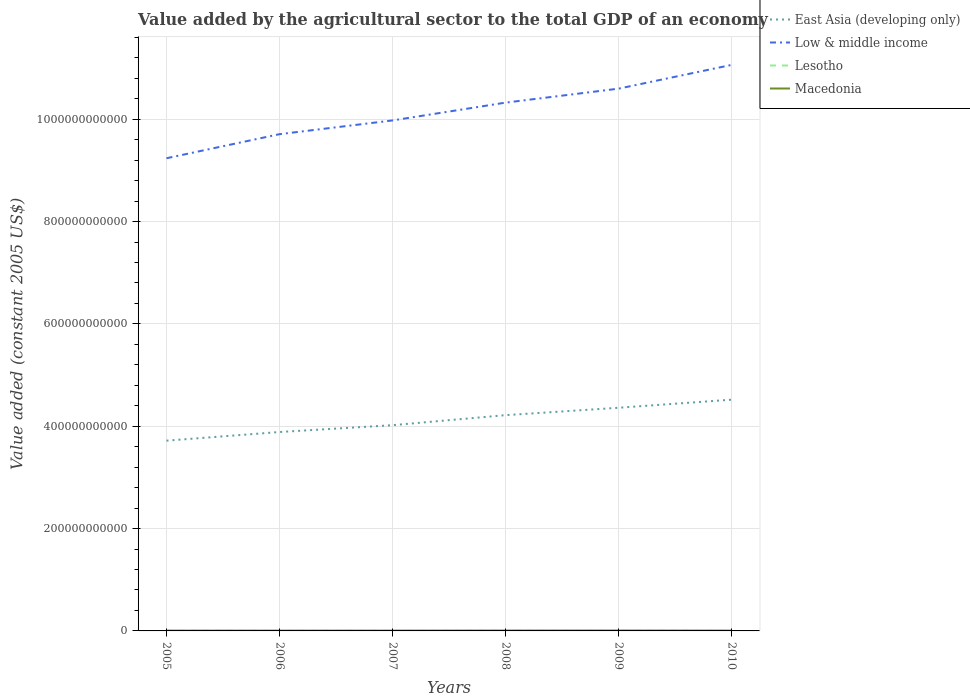How many different coloured lines are there?
Offer a very short reply. 4. Does the line corresponding to Low & middle income intersect with the line corresponding to East Asia (developing only)?
Your response must be concise. No. Is the number of lines equal to the number of legend labels?
Offer a very short reply. Yes. Across all years, what is the maximum value added by the agricultural sector in Lesotho?
Make the answer very short. 1.01e+08. What is the total value added by the agricultural sector in East Asia (developing only) in the graph?
Ensure brevity in your answer.  -1.58e+1. What is the difference between the highest and the second highest value added by the agricultural sector in Low & middle income?
Give a very brief answer. 1.82e+11. What is the difference between the highest and the lowest value added by the agricultural sector in Low & middle income?
Offer a very short reply. 3. How many lines are there?
Provide a succinct answer. 4. How many years are there in the graph?
Ensure brevity in your answer.  6. What is the difference between two consecutive major ticks on the Y-axis?
Your answer should be very brief. 2.00e+11. Does the graph contain grids?
Your response must be concise. Yes. What is the title of the graph?
Your answer should be very brief. Value added by the agricultural sector to the total GDP of an economy. Does "Europe(all income levels)" appear as one of the legend labels in the graph?
Ensure brevity in your answer.  No. What is the label or title of the X-axis?
Your response must be concise. Years. What is the label or title of the Y-axis?
Provide a short and direct response. Value added (constant 2005 US$). What is the Value added (constant 2005 US$) of East Asia (developing only) in 2005?
Ensure brevity in your answer.  3.72e+11. What is the Value added (constant 2005 US$) in Low & middle income in 2005?
Offer a terse response. 9.24e+11. What is the Value added (constant 2005 US$) of Lesotho in 2005?
Make the answer very short. 1.13e+08. What is the Value added (constant 2005 US$) in Macedonia in 2005?
Give a very brief answer. 6.09e+08. What is the Value added (constant 2005 US$) in East Asia (developing only) in 2006?
Keep it short and to the point. 3.89e+11. What is the Value added (constant 2005 US$) in Low & middle income in 2006?
Provide a short and direct response. 9.71e+11. What is the Value added (constant 2005 US$) in Lesotho in 2006?
Give a very brief answer. 1.02e+08. What is the Value added (constant 2005 US$) of Macedonia in 2006?
Provide a short and direct response. 6.06e+08. What is the Value added (constant 2005 US$) in East Asia (developing only) in 2007?
Your response must be concise. 4.02e+11. What is the Value added (constant 2005 US$) of Low & middle income in 2007?
Your response must be concise. 9.98e+11. What is the Value added (constant 2005 US$) of Lesotho in 2007?
Keep it short and to the point. 1.01e+08. What is the Value added (constant 2005 US$) in Macedonia in 2007?
Ensure brevity in your answer.  6.19e+08. What is the Value added (constant 2005 US$) of East Asia (developing only) in 2008?
Offer a terse response. 4.22e+11. What is the Value added (constant 2005 US$) in Low & middle income in 2008?
Provide a short and direct response. 1.03e+12. What is the Value added (constant 2005 US$) in Lesotho in 2008?
Keep it short and to the point. 1.17e+08. What is the Value added (constant 2005 US$) in Macedonia in 2008?
Offer a terse response. 7.55e+08. What is the Value added (constant 2005 US$) in East Asia (developing only) in 2009?
Your response must be concise. 4.36e+11. What is the Value added (constant 2005 US$) in Low & middle income in 2009?
Your answer should be very brief. 1.06e+12. What is the Value added (constant 2005 US$) of Lesotho in 2009?
Make the answer very short. 1.11e+08. What is the Value added (constant 2005 US$) in Macedonia in 2009?
Your response must be concise. 7.81e+08. What is the Value added (constant 2005 US$) in East Asia (developing only) in 2010?
Provide a short and direct response. 4.52e+11. What is the Value added (constant 2005 US$) of Low & middle income in 2010?
Keep it short and to the point. 1.11e+12. What is the Value added (constant 2005 US$) of Lesotho in 2010?
Ensure brevity in your answer.  1.22e+08. What is the Value added (constant 2005 US$) in Macedonia in 2010?
Give a very brief answer. 6.76e+08. Across all years, what is the maximum Value added (constant 2005 US$) in East Asia (developing only)?
Your answer should be very brief. 4.52e+11. Across all years, what is the maximum Value added (constant 2005 US$) of Low & middle income?
Provide a succinct answer. 1.11e+12. Across all years, what is the maximum Value added (constant 2005 US$) of Lesotho?
Ensure brevity in your answer.  1.22e+08. Across all years, what is the maximum Value added (constant 2005 US$) in Macedonia?
Your answer should be compact. 7.81e+08. Across all years, what is the minimum Value added (constant 2005 US$) of East Asia (developing only)?
Your answer should be compact. 3.72e+11. Across all years, what is the minimum Value added (constant 2005 US$) of Low & middle income?
Ensure brevity in your answer.  9.24e+11. Across all years, what is the minimum Value added (constant 2005 US$) in Lesotho?
Your answer should be compact. 1.01e+08. Across all years, what is the minimum Value added (constant 2005 US$) of Macedonia?
Offer a terse response. 6.06e+08. What is the total Value added (constant 2005 US$) of East Asia (developing only) in the graph?
Ensure brevity in your answer.  2.47e+12. What is the total Value added (constant 2005 US$) in Low & middle income in the graph?
Make the answer very short. 6.09e+12. What is the total Value added (constant 2005 US$) in Lesotho in the graph?
Your response must be concise. 6.67e+08. What is the total Value added (constant 2005 US$) of Macedonia in the graph?
Your response must be concise. 4.05e+09. What is the difference between the Value added (constant 2005 US$) of East Asia (developing only) in 2005 and that in 2006?
Give a very brief answer. -1.69e+1. What is the difference between the Value added (constant 2005 US$) of Low & middle income in 2005 and that in 2006?
Your answer should be compact. -4.70e+1. What is the difference between the Value added (constant 2005 US$) of Lesotho in 2005 and that in 2006?
Your response must be concise. 1.17e+07. What is the difference between the Value added (constant 2005 US$) in Macedonia in 2005 and that in 2006?
Your response must be concise. 3.31e+06. What is the difference between the Value added (constant 2005 US$) in East Asia (developing only) in 2005 and that in 2007?
Provide a succinct answer. -3.03e+1. What is the difference between the Value added (constant 2005 US$) of Low & middle income in 2005 and that in 2007?
Offer a very short reply. -7.39e+1. What is the difference between the Value added (constant 2005 US$) in Lesotho in 2005 and that in 2007?
Your response must be concise. 1.26e+07. What is the difference between the Value added (constant 2005 US$) in Macedonia in 2005 and that in 2007?
Offer a very short reply. -9.75e+06. What is the difference between the Value added (constant 2005 US$) in East Asia (developing only) in 2005 and that in 2008?
Ensure brevity in your answer.  -4.99e+1. What is the difference between the Value added (constant 2005 US$) in Low & middle income in 2005 and that in 2008?
Make the answer very short. -1.09e+11. What is the difference between the Value added (constant 2005 US$) of Lesotho in 2005 and that in 2008?
Ensure brevity in your answer.  -3.69e+06. What is the difference between the Value added (constant 2005 US$) in Macedonia in 2005 and that in 2008?
Provide a succinct answer. -1.46e+08. What is the difference between the Value added (constant 2005 US$) of East Asia (developing only) in 2005 and that in 2009?
Your response must be concise. -6.43e+1. What is the difference between the Value added (constant 2005 US$) in Low & middle income in 2005 and that in 2009?
Offer a very short reply. -1.36e+11. What is the difference between the Value added (constant 2005 US$) of Lesotho in 2005 and that in 2009?
Your answer should be very brief. 2.24e+06. What is the difference between the Value added (constant 2005 US$) in Macedonia in 2005 and that in 2009?
Your answer should be very brief. -1.72e+08. What is the difference between the Value added (constant 2005 US$) of East Asia (developing only) in 2005 and that in 2010?
Provide a succinct answer. -8.01e+1. What is the difference between the Value added (constant 2005 US$) of Low & middle income in 2005 and that in 2010?
Your answer should be compact. -1.82e+11. What is the difference between the Value added (constant 2005 US$) in Lesotho in 2005 and that in 2010?
Provide a succinct answer. -9.10e+06. What is the difference between the Value added (constant 2005 US$) of Macedonia in 2005 and that in 2010?
Your response must be concise. -6.71e+07. What is the difference between the Value added (constant 2005 US$) in East Asia (developing only) in 2006 and that in 2007?
Ensure brevity in your answer.  -1.34e+1. What is the difference between the Value added (constant 2005 US$) of Low & middle income in 2006 and that in 2007?
Make the answer very short. -2.69e+1. What is the difference between the Value added (constant 2005 US$) of Lesotho in 2006 and that in 2007?
Your response must be concise. 9.36e+05. What is the difference between the Value added (constant 2005 US$) in Macedonia in 2006 and that in 2007?
Ensure brevity in your answer.  -1.31e+07. What is the difference between the Value added (constant 2005 US$) of East Asia (developing only) in 2006 and that in 2008?
Keep it short and to the point. -3.30e+1. What is the difference between the Value added (constant 2005 US$) of Low & middle income in 2006 and that in 2008?
Provide a succinct answer. -6.17e+1. What is the difference between the Value added (constant 2005 US$) of Lesotho in 2006 and that in 2008?
Give a very brief answer. -1.54e+07. What is the difference between the Value added (constant 2005 US$) of Macedonia in 2006 and that in 2008?
Make the answer very short. -1.49e+08. What is the difference between the Value added (constant 2005 US$) in East Asia (developing only) in 2006 and that in 2009?
Provide a succinct answer. -4.74e+1. What is the difference between the Value added (constant 2005 US$) in Low & middle income in 2006 and that in 2009?
Your answer should be very brief. -8.90e+1. What is the difference between the Value added (constant 2005 US$) of Lesotho in 2006 and that in 2009?
Offer a very short reply. -9.45e+06. What is the difference between the Value added (constant 2005 US$) of Macedonia in 2006 and that in 2009?
Ensure brevity in your answer.  -1.75e+08. What is the difference between the Value added (constant 2005 US$) of East Asia (developing only) in 2006 and that in 2010?
Your answer should be compact. -6.32e+1. What is the difference between the Value added (constant 2005 US$) in Low & middle income in 2006 and that in 2010?
Your response must be concise. -1.35e+11. What is the difference between the Value added (constant 2005 US$) of Lesotho in 2006 and that in 2010?
Ensure brevity in your answer.  -2.08e+07. What is the difference between the Value added (constant 2005 US$) of Macedonia in 2006 and that in 2010?
Ensure brevity in your answer.  -7.04e+07. What is the difference between the Value added (constant 2005 US$) of East Asia (developing only) in 2007 and that in 2008?
Offer a very short reply. -1.96e+1. What is the difference between the Value added (constant 2005 US$) in Low & middle income in 2007 and that in 2008?
Make the answer very short. -3.48e+1. What is the difference between the Value added (constant 2005 US$) in Lesotho in 2007 and that in 2008?
Make the answer very short. -1.63e+07. What is the difference between the Value added (constant 2005 US$) of Macedonia in 2007 and that in 2008?
Ensure brevity in your answer.  -1.36e+08. What is the difference between the Value added (constant 2005 US$) in East Asia (developing only) in 2007 and that in 2009?
Your answer should be compact. -3.40e+1. What is the difference between the Value added (constant 2005 US$) of Low & middle income in 2007 and that in 2009?
Give a very brief answer. -6.21e+1. What is the difference between the Value added (constant 2005 US$) of Lesotho in 2007 and that in 2009?
Your answer should be very brief. -1.04e+07. What is the difference between the Value added (constant 2005 US$) of Macedonia in 2007 and that in 2009?
Provide a succinct answer. -1.62e+08. What is the difference between the Value added (constant 2005 US$) of East Asia (developing only) in 2007 and that in 2010?
Your answer should be very brief. -4.99e+1. What is the difference between the Value added (constant 2005 US$) of Low & middle income in 2007 and that in 2010?
Your response must be concise. -1.09e+11. What is the difference between the Value added (constant 2005 US$) in Lesotho in 2007 and that in 2010?
Offer a terse response. -2.17e+07. What is the difference between the Value added (constant 2005 US$) of Macedonia in 2007 and that in 2010?
Provide a short and direct response. -5.73e+07. What is the difference between the Value added (constant 2005 US$) of East Asia (developing only) in 2008 and that in 2009?
Give a very brief answer. -1.45e+1. What is the difference between the Value added (constant 2005 US$) of Low & middle income in 2008 and that in 2009?
Offer a very short reply. -2.73e+1. What is the difference between the Value added (constant 2005 US$) of Lesotho in 2008 and that in 2009?
Provide a succinct answer. 5.93e+06. What is the difference between the Value added (constant 2005 US$) of Macedonia in 2008 and that in 2009?
Your answer should be compact. -2.57e+07. What is the difference between the Value added (constant 2005 US$) in East Asia (developing only) in 2008 and that in 2010?
Your answer should be compact. -3.03e+1. What is the difference between the Value added (constant 2005 US$) in Low & middle income in 2008 and that in 2010?
Give a very brief answer. -7.38e+1. What is the difference between the Value added (constant 2005 US$) in Lesotho in 2008 and that in 2010?
Give a very brief answer. -5.41e+06. What is the difference between the Value added (constant 2005 US$) in Macedonia in 2008 and that in 2010?
Ensure brevity in your answer.  7.88e+07. What is the difference between the Value added (constant 2005 US$) in East Asia (developing only) in 2009 and that in 2010?
Ensure brevity in your answer.  -1.58e+1. What is the difference between the Value added (constant 2005 US$) in Low & middle income in 2009 and that in 2010?
Offer a very short reply. -4.64e+1. What is the difference between the Value added (constant 2005 US$) of Lesotho in 2009 and that in 2010?
Provide a succinct answer. -1.13e+07. What is the difference between the Value added (constant 2005 US$) of Macedonia in 2009 and that in 2010?
Provide a short and direct response. 1.05e+08. What is the difference between the Value added (constant 2005 US$) of East Asia (developing only) in 2005 and the Value added (constant 2005 US$) of Low & middle income in 2006?
Provide a succinct answer. -5.99e+11. What is the difference between the Value added (constant 2005 US$) in East Asia (developing only) in 2005 and the Value added (constant 2005 US$) in Lesotho in 2006?
Make the answer very short. 3.72e+11. What is the difference between the Value added (constant 2005 US$) of East Asia (developing only) in 2005 and the Value added (constant 2005 US$) of Macedonia in 2006?
Offer a very short reply. 3.71e+11. What is the difference between the Value added (constant 2005 US$) of Low & middle income in 2005 and the Value added (constant 2005 US$) of Lesotho in 2006?
Offer a terse response. 9.24e+11. What is the difference between the Value added (constant 2005 US$) of Low & middle income in 2005 and the Value added (constant 2005 US$) of Macedonia in 2006?
Your response must be concise. 9.23e+11. What is the difference between the Value added (constant 2005 US$) in Lesotho in 2005 and the Value added (constant 2005 US$) in Macedonia in 2006?
Offer a terse response. -4.93e+08. What is the difference between the Value added (constant 2005 US$) in East Asia (developing only) in 2005 and the Value added (constant 2005 US$) in Low & middle income in 2007?
Make the answer very short. -6.26e+11. What is the difference between the Value added (constant 2005 US$) in East Asia (developing only) in 2005 and the Value added (constant 2005 US$) in Lesotho in 2007?
Offer a very short reply. 3.72e+11. What is the difference between the Value added (constant 2005 US$) of East Asia (developing only) in 2005 and the Value added (constant 2005 US$) of Macedonia in 2007?
Offer a terse response. 3.71e+11. What is the difference between the Value added (constant 2005 US$) in Low & middle income in 2005 and the Value added (constant 2005 US$) in Lesotho in 2007?
Give a very brief answer. 9.24e+11. What is the difference between the Value added (constant 2005 US$) in Low & middle income in 2005 and the Value added (constant 2005 US$) in Macedonia in 2007?
Your answer should be very brief. 9.23e+11. What is the difference between the Value added (constant 2005 US$) of Lesotho in 2005 and the Value added (constant 2005 US$) of Macedonia in 2007?
Your response must be concise. -5.06e+08. What is the difference between the Value added (constant 2005 US$) of East Asia (developing only) in 2005 and the Value added (constant 2005 US$) of Low & middle income in 2008?
Offer a very short reply. -6.61e+11. What is the difference between the Value added (constant 2005 US$) in East Asia (developing only) in 2005 and the Value added (constant 2005 US$) in Lesotho in 2008?
Provide a succinct answer. 3.72e+11. What is the difference between the Value added (constant 2005 US$) of East Asia (developing only) in 2005 and the Value added (constant 2005 US$) of Macedonia in 2008?
Provide a succinct answer. 3.71e+11. What is the difference between the Value added (constant 2005 US$) of Low & middle income in 2005 and the Value added (constant 2005 US$) of Lesotho in 2008?
Your response must be concise. 9.24e+11. What is the difference between the Value added (constant 2005 US$) of Low & middle income in 2005 and the Value added (constant 2005 US$) of Macedonia in 2008?
Your answer should be compact. 9.23e+11. What is the difference between the Value added (constant 2005 US$) in Lesotho in 2005 and the Value added (constant 2005 US$) in Macedonia in 2008?
Your answer should be very brief. -6.42e+08. What is the difference between the Value added (constant 2005 US$) of East Asia (developing only) in 2005 and the Value added (constant 2005 US$) of Low & middle income in 2009?
Offer a terse response. -6.88e+11. What is the difference between the Value added (constant 2005 US$) in East Asia (developing only) in 2005 and the Value added (constant 2005 US$) in Lesotho in 2009?
Provide a succinct answer. 3.72e+11. What is the difference between the Value added (constant 2005 US$) in East Asia (developing only) in 2005 and the Value added (constant 2005 US$) in Macedonia in 2009?
Your answer should be very brief. 3.71e+11. What is the difference between the Value added (constant 2005 US$) in Low & middle income in 2005 and the Value added (constant 2005 US$) in Lesotho in 2009?
Provide a succinct answer. 9.24e+11. What is the difference between the Value added (constant 2005 US$) in Low & middle income in 2005 and the Value added (constant 2005 US$) in Macedonia in 2009?
Keep it short and to the point. 9.23e+11. What is the difference between the Value added (constant 2005 US$) in Lesotho in 2005 and the Value added (constant 2005 US$) in Macedonia in 2009?
Offer a terse response. -6.68e+08. What is the difference between the Value added (constant 2005 US$) of East Asia (developing only) in 2005 and the Value added (constant 2005 US$) of Low & middle income in 2010?
Offer a very short reply. -7.34e+11. What is the difference between the Value added (constant 2005 US$) in East Asia (developing only) in 2005 and the Value added (constant 2005 US$) in Lesotho in 2010?
Ensure brevity in your answer.  3.72e+11. What is the difference between the Value added (constant 2005 US$) of East Asia (developing only) in 2005 and the Value added (constant 2005 US$) of Macedonia in 2010?
Ensure brevity in your answer.  3.71e+11. What is the difference between the Value added (constant 2005 US$) of Low & middle income in 2005 and the Value added (constant 2005 US$) of Lesotho in 2010?
Provide a short and direct response. 9.24e+11. What is the difference between the Value added (constant 2005 US$) in Low & middle income in 2005 and the Value added (constant 2005 US$) in Macedonia in 2010?
Give a very brief answer. 9.23e+11. What is the difference between the Value added (constant 2005 US$) of Lesotho in 2005 and the Value added (constant 2005 US$) of Macedonia in 2010?
Your answer should be compact. -5.63e+08. What is the difference between the Value added (constant 2005 US$) in East Asia (developing only) in 2006 and the Value added (constant 2005 US$) in Low & middle income in 2007?
Ensure brevity in your answer.  -6.09e+11. What is the difference between the Value added (constant 2005 US$) in East Asia (developing only) in 2006 and the Value added (constant 2005 US$) in Lesotho in 2007?
Keep it short and to the point. 3.89e+11. What is the difference between the Value added (constant 2005 US$) of East Asia (developing only) in 2006 and the Value added (constant 2005 US$) of Macedonia in 2007?
Your answer should be compact. 3.88e+11. What is the difference between the Value added (constant 2005 US$) in Low & middle income in 2006 and the Value added (constant 2005 US$) in Lesotho in 2007?
Offer a very short reply. 9.71e+11. What is the difference between the Value added (constant 2005 US$) in Low & middle income in 2006 and the Value added (constant 2005 US$) in Macedonia in 2007?
Ensure brevity in your answer.  9.70e+11. What is the difference between the Value added (constant 2005 US$) in Lesotho in 2006 and the Value added (constant 2005 US$) in Macedonia in 2007?
Make the answer very short. -5.17e+08. What is the difference between the Value added (constant 2005 US$) of East Asia (developing only) in 2006 and the Value added (constant 2005 US$) of Low & middle income in 2008?
Provide a short and direct response. -6.44e+11. What is the difference between the Value added (constant 2005 US$) of East Asia (developing only) in 2006 and the Value added (constant 2005 US$) of Lesotho in 2008?
Your answer should be very brief. 3.89e+11. What is the difference between the Value added (constant 2005 US$) in East Asia (developing only) in 2006 and the Value added (constant 2005 US$) in Macedonia in 2008?
Provide a succinct answer. 3.88e+11. What is the difference between the Value added (constant 2005 US$) of Low & middle income in 2006 and the Value added (constant 2005 US$) of Lesotho in 2008?
Provide a short and direct response. 9.71e+11. What is the difference between the Value added (constant 2005 US$) in Low & middle income in 2006 and the Value added (constant 2005 US$) in Macedonia in 2008?
Make the answer very short. 9.70e+11. What is the difference between the Value added (constant 2005 US$) in Lesotho in 2006 and the Value added (constant 2005 US$) in Macedonia in 2008?
Provide a succinct answer. -6.54e+08. What is the difference between the Value added (constant 2005 US$) in East Asia (developing only) in 2006 and the Value added (constant 2005 US$) in Low & middle income in 2009?
Give a very brief answer. -6.71e+11. What is the difference between the Value added (constant 2005 US$) in East Asia (developing only) in 2006 and the Value added (constant 2005 US$) in Lesotho in 2009?
Give a very brief answer. 3.89e+11. What is the difference between the Value added (constant 2005 US$) of East Asia (developing only) in 2006 and the Value added (constant 2005 US$) of Macedonia in 2009?
Ensure brevity in your answer.  3.88e+11. What is the difference between the Value added (constant 2005 US$) of Low & middle income in 2006 and the Value added (constant 2005 US$) of Lesotho in 2009?
Your answer should be compact. 9.71e+11. What is the difference between the Value added (constant 2005 US$) in Low & middle income in 2006 and the Value added (constant 2005 US$) in Macedonia in 2009?
Your response must be concise. 9.70e+11. What is the difference between the Value added (constant 2005 US$) of Lesotho in 2006 and the Value added (constant 2005 US$) of Macedonia in 2009?
Your response must be concise. -6.79e+08. What is the difference between the Value added (constant 2005 US$) in East Asia (developing only) in 2006 and the Value added (constant 2005 US$) in Low & middle income in 2010?
Your response must be concise. -7.18e+11. What is the difference between the Value added (constant 2005 US$) of East Asia (developing only) in 2006 and the Value added (constant 2005 US$) of Lesotho in 2010?
Provide a succinct answer. 3.89e+11. What is the difference between the Value added (constant 2005 US$) of East Asia (developing only) in 2006 and the Value added (constant 2005 US$) of Macedonia in 2010?
Keep it short and to the point. 3.88e+11. What is the difference between the Value added (constant 2005 US$) in Low & middle income in 2006 and the Value added (constant 2005 US$) in Lesotho in 2010?
Your response must be concise. 9.71e+11. What is the difference between the Value added (constant 2005 US$) in Low & middle income in 2006 and the Value added (constant 2005 US$) in Macedonia in 2010?
Your answer should be very brief. 9.70e+11. What is the difference between the Value added (constant 2005 US$) of Lesotho in 2006 and the Value added (constant 2005 US$) of Macedonia in 2010?
Your answer should be compact. -5.75e+08. What is the difference between the Value added (constant 2005 US$) of East Asia (developing only) in 2007 and the Value added (constant 2005 US$) of Low & middle income in 2008?
Provide a succinct answer. -6.30e+11. What is the difference between the Value added (constant 2005 US$) in East Asia (developing only) in 2007 and the Value added (constant 2005 US$) in Lesotho in 2008?
Your answer should be very brief. 4.02e+11. What is the difference between the Value added (constant 2005 US$) in East Asia (developing only) in 2007 and the Value added (constant 2005 US$) in Macedonia in 2008?
Your answer should be very brief. 4.01e+11. What is the difference between the Value added (constant 2005 US$) of Low & middle income in 2007 and the Value added (constant 2005 US$) of Lesotho in 2008?
Provide a short and direct response. 9.98e+11. What is the difference between the Value added (constant 2005 US$) in Low & middle income in 2007 and the Value added (constant 2005 US$) in Macedonia in 2008?
Provide a short and direct response. 9.97e+11. What is the difference between the Value added (constant 2005 US$) of Lesotho in 2007 and the Value added (constant 2005 US$) of Macedonia in 2008?
Provide a short and direct response. -6.54e+08. What is the difference between the Value added (constant 2005 US$) of East Asia (developing only) in 2007 and the Value added (constant 2005 US$) of Low & middle income in 2009?
Your response must be concise. -6.58e+11. What is the difference between the Value added (constant 2005 US$) of East Asia (developing only) in 2007 and the Value added (constant 2005 US$) of Lesotho in 2009?
Your answer should be very brief. 4.02e+11. What is the difference between the Value added (constant 2005 US$) of East Asia (developing only) in 2007 and the Value added (constant 2005 US$) of Macedonia in 2009?
Your answer should be compact. 4.01e+11. What is the difference between the Value added (constant 2005 US$) of Low & middle income in 2007 and the Value added (constant 2005 US$) of Lesotho in 2009?
Make the answer very short. 9.98e+11. What is the difference between the Value added (constant 2005 US$) in Low & middle income in 2007 and the Value added (constant 2005 US$) in Macedonia in 2009?
Keep it short and to the point. 9.97e+11. What is the difference between the Value added (constant 2005 US$) of Lesotho in 2007 and the Value added (constant 2005 US$) of Macedonia in 2009?
Your response must be concise. -6.80e+08. What is the difference between the Value added (constant 2005 US$) of East Asia (developing only) in 2007 and the Value added (constant 2005 US$) of Low & middle income in 2010?
Give a very brief answer. -7.04e+11. What is the difference between the Value added (constant 2005 US$) of East Asia (developing only) in 2007 and the Value added (constant 2005 US$) of Lesotho in 2010?
Your answer should be compact. 4.02e+11. What is the difference between the Value added (constant 2005 US$) of East Asia (developing only) in 2007 and the Value added (constant 2005 US$) of Macedonia in 2010?
Offer a very short reply. 4.01e+11. What is the difference between the Value added (constant 2005 US$) of Low & middle income in 2007 and the Value added (constant 2005 US$) of Lesotho in 2010?
Provide a short and direct response. 9.98e+11. What is the difference between the Value added (constant 2005 US$) in Low & middle income in 2007 and the Value added (constant 2005 US$) in Macedonia in 2010?
Make the answer very short. 9.97e+11. What is the difference between the Value added (constant 2005 US$) in Lesotho in 2007 and the Value added (constant 2005 US$) in Macedonia in 2010?
Your response must be concise. -5.76e+08. What is the difference between the Value added (constant 2005 US$) of East Asia (developing only) in 2008 and the Value added (constant 2005 US$) of Low & middle income in 2009?
Provide a short and direct response. -6.38e+11. What is the difference between the Value added (constant 2005 US$) in East Asia (developing only) in 2008 and the Value added (constant 2005 US$) in Lesotho in 2009?
Provide a short and direct response. 4.22e+11. What is the difference between the Value added (constant 2005 US$) of East Asia (developing only) in 2008 and the Value added (constant 2005 US$) of Macedonia in 2009?
Ensure brevity in your answer.  4.21e+11. What is the difference between the Value added (constant 2005 US$) in Low & middle income in 2008 and the Value added (constant 2005 US$) in Lesotho in 2009?
Provide a succinct answer. 1.03e+12. What is the difference between the Value added (constant 2005 US$) of Low & middle income in 2008 and the Value added (constant 2005 US$) of Macedonia in 2009?
Provide a succinct answer. 1.03e+12. What is the difference between the Value added (constant 2005 US$) of Lesotho in 2008 and the Value added (constant 2005 US$) of Macedonia in 2009?
Your answer should be very brief. -6.64e+08. What is the difference between the Value added (constant 2005 US$) of East Asia (developing only) in 2008 and the Value added (constant 2005 US$) of Low & middle income in 2010?
Your answer should be compact. -6.85e+11. What is the difference between the Value added (constant 2005 US$) in East Asia (developing only) in 2008 and the Value added (constant 2005 US$) in Lesotho in 2010?
Ensure brevity in your answer.  4.22e+11. What is the difference between the Value added (constant 2005 US$) in East Asia (developing only) in 2008 and the Value added (constant 2005 US$) in Macedonia in 2010?
Your response must be concise. 4.21e+11. What is the difference between the Value added (constant 2005 US$) of Low & middle income in 2008 and the Value added (constant 2005 US$) of Lesotho in 2010?
Your answer should be very brief. 1.03e+12. What is the difference between the Value added (constant 2005 US$) of Low & middle income in 2008 and the Value added (constant 2005 US$) of Macedonia in 2010?
Give a very brief answer. 1.03e+12. What is the difference between the Value added (constant 2005 US$) of Lesotho in 2008 and the Value added (constant 2005 US$) of Macedonia in 2010?
Offer a terse response. -5.59e+08. What is the difference between the Value added (constant 2005 US$) in East Asia (developing only) in 2009 and the Value added (constant 2005 US$) in Low & middle income in 2010?
Provide a succinct answer. -6.70e+11. What is the difference between the Value added (constant 2005 US$) in East Asia (developing only) in 2009 and the Value added (constant 2005 US$) in Lesotho in 2010?
Provide a short and direct response. 4.36e+11. What is the difference between the Value added (constant 2005 US$) in East Asia (developing only) in 2009 and the Value added (constant 2005 US$) in Macedonia in 2010?
Provide a short and direct response. 4.35e+11. What is the difference between the Value added (constant 2005 US$) of Low & middle income in 2009 and the Value added (constant 2005 US$) of Lesotho in 2010?
Provide a short and direct response. 1.06e+12. What is the difference between the Value added (constant 2005 US$) of Low & middle income in 2009 and the Value added (constant 2005 US$) of Macedonia in 2010?
Keep it short and to the point. 1.06e+12. What is the difference between the Value added (constant 2005 US$) of Lesotho in 2009 and the Value added (constant 2005 US$) of Macedonia in 2010?
Your answer should be compact. -5.65e+08. What is the average Value added (constant 2005 US$) of East Asia (developing only) per year?
Ensure brevity in your answer.  4.12e+11. What is the average Value added (constant 2005 US$) of Low & middle income per year?
Offer a terse response. 1.02e+12. What is the average Value added (constant 2005 US$) of Lesotho per year?
Keep it short and to the point. 1.11e+08. What is the average Value added (constant 2005 US$) of Macedonia per year?
Ensure brevity in your answer.  6.75e+08. In the year 2005, what is the difference between the Value added (constant 2005 US$) in East Asia (developing only) and Value added (constant 2005 US$) in Low & middle income?
Your answer should be compact. -5.52e+11. In the year 2005, what is the difference between the Value added (constant 2005 US$) of East Asia (developing only) and Value added (constant 2005 US$) of Lesotho?
Your response must be concise. 3.72e+11. In the year 2005, what is the difference between the Value added (constant 2005 US$) of East Asia (developing only) and Value added (constant 2005 US$) of Macedonia?
Ensure brevity in your answer.  3.71e+11. In the year 2005, what is the difference between the Value added (constant 2005 US$) of Low & middle income and Value added (constant 2005 US$) of Lesotho?
Provide a succinct answer. 9.24e+11. In the year 2005, what is the difference between the Value added (constant 2005 US$) of Low & middle income and Value added (constant 2005 US$) of Macedonia?
Give a very brief answer. 9.23e+11. In the year 2005, what is the difference between the Value added (constant 2005 US$) of Lesotho and Value added (constant 2005 US$) of Macedonia?
Your answer should be compact. -4.96e+08. In the year 2006, what is the difference between the Value added (constant 2005 US$) in East Asia (developing only) and Value added (constant 2005 US$) in Low & middle income?
Offer a very short reply. -5.82e+11. In the year 2006, what is the difference between the Value added (constant 2005 US$) in East Asia (developing only) and Value added (constant 2005 US$) in Lesotho?
Offer a terse response. 3.89e+11. In the year 2006, what is the difference between the Value added (constant 2005 US$) in East Asia (developing only) and Value added (constant 2005 US$) in Macedonia?
Your response must be concise. 3.88e+11. In the year 2006, what is the difference between the Value added (constant 2005 US$) of Low & middle income and Value added (constant 2005 US$) of Lesotho?
Provide a succinct answer. 9.71e+11. In the year 2006, what is the difference between the Value added (constant 2005 US$) in Low & middle income and Value added (constant 2005 US$) in Macedonia?
Your response must be concise. 9.70e+11. In the year 2006, what is the difference between the Value added (constant 2005 US$) in Lesotho and Value added (constant 2005 US$) in Macedonia?
Your answer should be very brief. -5.04e+08. In the year 2007, what is the difference between the Value added (constant 2005 US$) in East Asia (developing only) and Value added (constant 2005 US$) in Low & middle income?
Your response must be concise. -5.96e+11. In the year 2007, what is the difference between the Value added (constant 2005 US$) of East Asia (developing only) and Value added (constant 2005 US$) of Lesotho?
Make the answer very short. 4.02e+11. In the year 2007, what is the difference between the Value added (constant 2005 US$) in East Asia (developing only) and Value added (constant 2005 US$) in Macedonia?
Provide a succinct answer. 4.01e+11. In the year 2007, what is the difference between the Value added (constant 2005 US$) of Low & middle income and Value added (constant 2005 US$) of Lesotho?
Your response must be concise. 9.98e+11. In the year 2007, what is the difference between the Value added (constant 2005 US$) in Low & middle income and Value added (constant 2005 US$) in Macedonia?
Ensure brevity in your answer.  9.97e+11. In the year 2007, what is the difference between the Value added (constant 2005 US$) of Lesotho and Value added (constant 2005 US$) of Macedonia?
Provide a short and direct response. -5.18e+08. In the year 2008, what is the difference between the Value added (constant 2005 US$) of East Asia (developing only) and Value added (constant 2005 US$) of Low & middle income?
Your answer should be compact. -6.11e+11. In the year 2008, what is the difference between the Value added (constant 2005 US$) of East Asia (developing only) and Value added (constant 2005 US$) of Lesotho?
Give a very brief answer. 4.22e+11. In the year 2008, what is the difference between the Value added (constant 2005 US$) of East Asia (developing only) and Value added (constant 2005 US$) of Macedonia?
Your answer should be very brief. 4.21e+11. In the year 2008, what is the difference between the Value added (constant 2005 US$) of Low & middle income and Value added (constant 2005 US$) of Lesotho?
Offer a terse response. 1.03e+12. In the year 2008, what is the difference between the Value added (constant 2005 US$) in Low & middle income and Value added (constant 2005 US$) in Macedonia?
Keep it short and to the point. 1.03e+12. In the year 2008, what is the difference between the Value added (constant 2005 US$) of Lesotho and Value added (constant 2005 US$) of Macedonia?
Ensure brevity in your answer.  -6.38e+08. In the year 2009, what is the difference between the Value added (constant 2005 US$) in East Asia (developing only) and Value added (constant 2005 US$) in Low & middle income?
Make the answer very short. -6.24e+11. In the year 2009, what is the difference between the Value added (constant 2005 US$) in East Asia (developing only) and Value added (constant 2005 US$) in Lesotho?
Keep it short and to the point. 4.36e+11. In the year 2009, what is the difference between the Value added (constant 2005 US$) of East Asia (developing only) and Value added (constant 2005 US$) of Macedonia?
Keep it short and to the point. 4.35e+11. In the year 2009, what is the difference between the Value added (constant 2005 US$) of Low & middle income and Value added (constant 2005 US$) of Lesotho?
Give a very brief answer. 1.06e+12. In the year 2009, what is the difference between the Value added (constant 2005 US$) of Low & middle income and Value added (constant 2005 US$) of Macedonia?
Make the answer very short. 1.06e+12. In the year 2009, what is the difference between the Value added (constant 2005 US$) of Lesotho and Value added (constant 2005 US$) of Macedonia?
Your response must be concise. -6.70e+08. In the year 2010, what is the difference between the Value added (constant 2005 US$) in East Asia (developing only) and Value added (constant 2005 US$) in Low & middle income?
Give a very brief answer. -6.54e+11. In the year 2010, what is the difference between the Value added (constant 2005 US$) of East Asia (developing only) and Value added (constant 2005 US$) of Lesotho?
Offer a terse response. 4.52e+11. In the year 2010, what is the difference between the Value added (constant 2005 US$) in East Asia (developing only) and Value added (constant 2005 US$) in Macedonia?
Your response must be concise. 4.51e+11. In the year 2010, what is the difference between the Value added (constant 2005 US$) of Low & middle income and Value added (constant 2005 US$) of Lesotho?
Your answer should be very brief. 1.11e+12. In the year 2010, what is the difference between the Value added (constant 2005 US$) of Low & middle income and Value added (constant 2005 US$) of Macedonia?
Offer a terse response. 1.11e+12. In the year 2010, what is the difference between the Value added (constant 2005 US$) of Lesotho and Value added (constant 2005 US$) of Macedonia?
Your answer should be very brief. -5.54e+08. What is the ratio of the Value added (constant 2005 US$) of East Asia (developing only) in 2005 to that in 2006?
Offer a terse response. 0.96. What is the ratio of the Value added (constant 2005 US$) of Low & middle income in 2005 to that in 2006?
Your answer should be compact. 0.95. What is the ratio of the Value added (constant 2005 US$) of Lesotho in 2005 to that in 2006?
Provide a succinct answer. 1.11. What is the ratio of the Value added (constant 2005 US$) of East Asia (developing only) in 2005 to that in 2007?
Offer a very short reply. 0.92. What is the ratio of the Value added (constant 2005 US$) in Low & middle income in 2005 to that in 2007?
Offer a terse response. 0.93. What is the ratio of the Value added (constant 2005 US$) of Lesotho in 2005 to that in 2007?
Your answer should be compact. 1.13. What is the ratio of the Value added (constant 2005 US$) in Macedonia in 2005 to that in 2007?
Ensure brevity in your answer.  0.98. What is the ratio of the Value added (constant 2005 US$) of East Asia (developing only) in 2005 to that in 2008?
Ensure brevity in your answer.  0.88. What is the ratio of the Value added (constant 2005 US$) of Low & middle income in 2005 to that in 2008?
Offer a very short reply. 0.89. What is the ratio of the Value added (constant 2005 US$) of Lesotho in 2005 to that in 2008?
Provide a succinct answer. 0.97. What is the ratio of the Value added (constant 2005 US$) of Macedonia in 2005 to that in 2008?
Provide a succinct answer. 0.81. What is the ratio of the Value added (constant 2005 US$) in East Asia (developing only) in 2005 to that in 2009?
Give a very brief answer. 0.85. What is the ratio of the Value added (constant 2005 US$) of Low & middle income in 2005 to that in 2009?
Make the answer very short. 0.87. What is the ratio of the Value added (constant 2005 US$) in Lesotho in 2005 to that in 2009?
Offer a terse response. 1.02. What is the ratio of the Value added (constant 2005 US$) in Macedonia in 2005 to that in 2009?
Offer a terse response. 0.78. What is the ratio of the Value added (constant 2005 US$) in East Asia (developing only) in 2005 to that in 2010?
Offer a very short reply. 0.82. What is the ratio of the Value added (constant 2005 US$) of Low & middle income in 2005 to that in 2010?
Give a very brief answer. 0.84. What is the ratio of the Value added (constant 2005 US$) of Lesotho in 2005 to that in 2010?
Keep it short and to the point. 0.93. What is the ratio of the Value added (constant 2005 US$) of Macedonia in 2005 to that in 2010?
Your answer should be very brief. 0.9. What is the ratio of the Value added (constant 2005 US$) of East Asia (developing only) in 2006 to that in 2007?
Your answer should be very brief. 0.97. What is the ratio of the Value added (constant 2005 US$) in Low & middle income in 2006 to that in 2007?
Ensure brevity in your answer.  0.97. What is the ratio of the Value added (constant 2005 US$) of Lesotho in 2006 to that in 2007?
Make the answer very short. 1.01. What is the ratio of the Value added (constant 2005 US$) of Macedonia in 2006 to that in 2007?
Keep it short and to the point. 0.98. What is the ratio of the Value added (constant 2005 US$) of East Asia (developing only) in 2006 to that in 2008?
Give a very brief answer. 0.92. What is the ratio of the Value added (constant 2005 US$) of Low & middle income in 2006 to that in 2008?
Offer a very short reply. 0.94. What is the ratio of the Value added (constant 2005 US$) in Lesotho in 2006 to that in 2008?
Provide a short and direct response. 0.87. What is the ratio of the Value added (constant 2005 US$) of Macedonia in 2006 to that in 2008?
Ensure brevity in your answer.  0.8. What is the ratio of the Value added (constant 2005 US$) of East Asia (developing only) in 2006 to that in 2009?
Your answer should be very brief. 0.89. What is the ratio of the Value added (constant 2005 US$) in Low & middle income in 2006 to that in 2009?
Give a very brief answer. 0.92. What is the ratio of the Value added (constant 2005 US$) in Lesotho in 2006 to that in 2009?
Offer a very short reply. 0.91. What is the ratio of the Value added (constant 2005 US$) of Macedonia in 2006 to that in 2009?
Offer a terse response. 0.78. What is the ratio of the Value added (constant 2005 US$) in East Asia (developing only) in 2006 to that in 2010?
Your response must be concise. 0.86. What is the ratio of the Value added (constant 2005 US$) in Low & middle income in 2006 to that in 2010?
Make the answer very short. 0.88. What is the ratio of the Value added (constant 2005 US$) of Lesotho in 2006 to that in 2010?
Make the answer very short. 0.83. What is the ratio of the Value added (constant 2005 US$) in Macedonia in 2006 to that in 2010?
Provide a short and direct response. 0.9. What is the ratio of the Value added (constant 2005 US$) of East Asia (developing only) in 2007 to that in 2008?
Offer a terse response. 0.95. What is the ratio of the Value added (constant 2005 US$) of Low & middle income in 2007 to that in 2008?
Your response must be concise. 0.97. What is the ratio of the Value added (constant 2005 US$) of Lesotho in 2007 to that in 2008?
Ensure brevity in your answer.  0.86. What is the ratio of the Value added (constant 2005 US$) in Macedonia in 2007 to that in 2008?
Your answer should be very brief. 0.82. What is the ratio of the Value added (constant 2005 US$) of East Asia (developing only) in 2007 to that in 2009?
Provide a succinct answer. 0.92. What is the ratio of the Value added (constant 2005 US$) of Low & middle income in 2007 to that in 2009?
Ensure brevity in your answer.  0.94. What is the ratio of the Value added (constant 2005 US$) in Lesotho in 2007 to that in 2009?
Offer a terse response. 0.91. What is the ratio of the Value added (constant 2005 US$) in Macedonia in 2007 to that in 2009?
Your response must be concise. 0.79. What is the ratio of the Value added (constant 2005 US$) of East Asia (developing only) in 2007 to that in 2010?
Keep it short and to the point. 0.89. What is the ratio of the Value added (constant 2005 US$) of Low & middle income in 2007 to that in 2010?
Provide a succinct answer. 0.9. What is the ratio of the Value added (constant 2005 US$) of Lesotho in 2007 to that in 2010?
Your answer should be very brief. 0.82. What is the ratio of the Value added (constant 2005 US$) in Macedonia in 2007 to that in 2010?
Give a very brief answer. 0.92. What is the ratio of the Value added (constant 2005 US$) of East Asia (developing only) in 2008 to that in 2009?
Your answer should be very brief. 0.97. What is the ratio of the Value added (constant 2005 US$) in Low & middle income in 2008 to that in 2009?
Your response must be concise. 0.97. What is the ratio of the Value added (constant 2005 US$) in Lesotho in 2008 to that in 2009?
Keep it short and to the point. 1.05. What is the ratio of the Value added (constant 2005 US$) in Macedonia in 2008 to that in 2009?
Keep it short and to the point. 0.97. What is the ratio of the Value added (constant 2005 US$) of East Asia (developing only) in 2008 to that in 2010?
Make the answer very short. 0.93. What is the ratio of the Value added (constant 2005 US$) in Lesotho in 2008 to that in 2010?
Your response must be concise. 0.96. What is the ratio of the Value added (constant 2005 US$) of Macedonia in 2008 to that in 2010?
Make the answer very short. 1.12. What is the ratio of the Value added (constant 2005 US$) of East Asia (developing only) in 2009 to that in 2010?
Provide a short and direct response. 0.96. What is the ratio of the Value added (constant 2005 US$) in Low & middle income in 2009 to that in 2010?
Your response must be concise. 0.96. What is the ratio of the Value added (constant 2005 US$) of Lesotho in 2009 to that in 2010?
Your answer should be very brief. 0.91. What is the ratio of the Value added (constant 2005 US$) of Macedonia in 2009 to that in 2010?
Your response must be concise. 1.15. What is the difference between the highest and the second highest Value added (constant 2005 US$) of East Asia (developing only)?
Offer a very short reply. 1.58e+1. What is the difference between the highest and the second highest Value added (constant 2005 US$) of Low & middle income?
Offer a terse response. 4.64e+1. What is the difference between the highest and the second highest Value added (constant 2005 US$) in Lesotho?
Your answer should be compact. 5.41e+06. What is the difference between the highest and the second highest Value added (constant 2005 US$) in Macedonia?
Your answer should be compact. 2.57e+07. What is the difference between the highest and the lowest Value added (constant 2005 US$) in East Asia (developing only)?
Offer a very short reply. 8.01e+1. What is the difference between the highest and the lowest Value added (constant 2005 US$) of Low & middle income?
Your answer should be compact. 1.82e+11. What is the difference between the highest and the lowest Value added (constant 2005 US$) in Lesotho?
Provide a succinct answer. 2.17e+07. What is the difference between the highest and the lowest Value added (constant 2005 US$) of Macedonia?
Make the answer very short. 1.75e+08. 